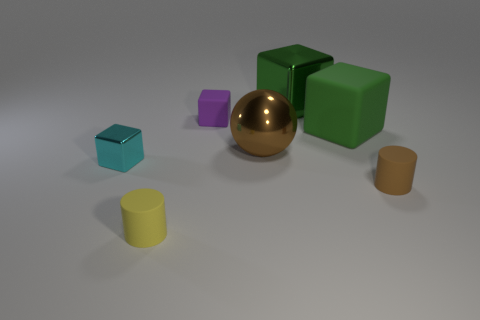Subtract all big green shiny cubes. How many cubes are left? 3 Add 2 tiny green balls. How many objects exist? 9 Subtract all blue blocks. Subtract all purple cylinders. How many blocks are left? 4 Subtract all cubes. How many objects are left? 3 Add 2 purple cubes. How many purple cubes are left? 3 Add 4 green objects. How many green objects exist? 6 Subtract 1 brown balls. How many objects are left? 6 Subtract all large brown metal things. Subtract all cyan objects. How many objects are left? 5 